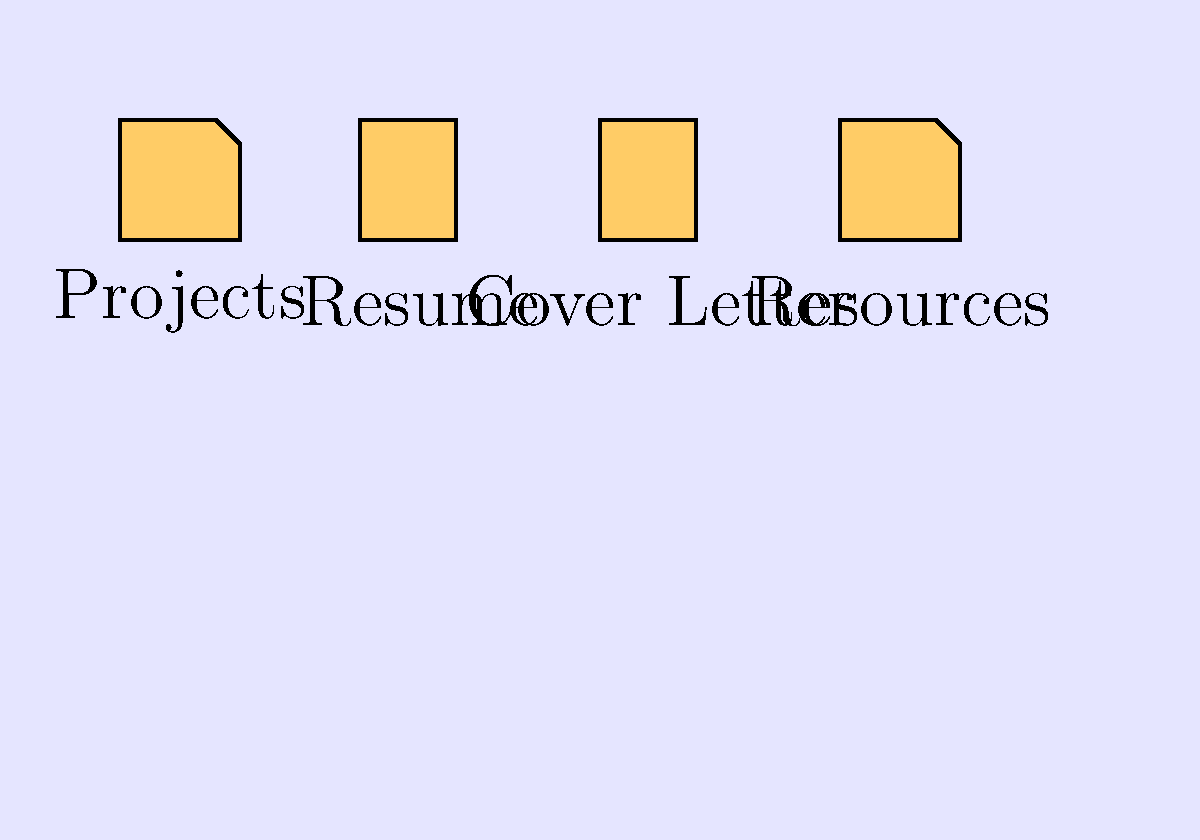As a computer skills instructor for underserved communities, you're teaching students about organizing their desktop for job searching. Given the arrangement of icons shown, which order would you recommend for the most efficient workflow when applying for jobs? To determine the most efficient workflow for job applications, let's analyze the icons and their purposes:

1. "Projects" folder: Contains examples of work to showcase skills.
2. "Resume" document: The primary document for job applications.
3. "Cover Letter" document: A customizable document for each application.
4. "Resources" folder: Likely contains job search tips, company information, etc.

The most efficient workflow would be:

Step 1: Start with the "Resume" as it's the foundation of any job application.
Step 2: Move to "Cover Letter" to customize it for the specific job.
Step 3: Access "Projects" to select relevant work samples to accompany the application.
Step 4: Finally, use "Resources" for any additional information or guidance needed.

This order allows for a logical progression from core application materials to supporting documents, ending with reference materials.
Answer: Resume, Cover Letter, Projects, Resources 